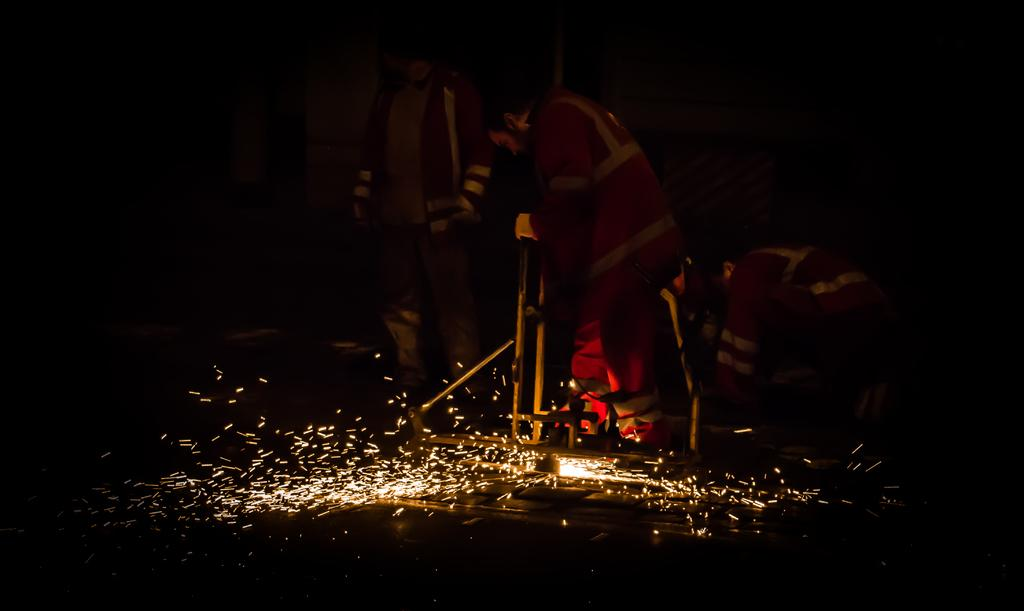What is the main subject of the image? The main subject of the image is a group of people. What are the people wearing in the image? The people are wearing red color jackets. What are the people doing in the image? The people are standing and doing some work. Can you describe any specific detail in the image? There is a spark visible in the image. What type of camp can be seen in the people working in the image? There is no camp present in the image; it features a group of people wearing red color jackets and doing some work. What type of machine is the person using to work with their hands in the image? There is no machine or hand-related work visible in the image; the people are simply standing and doing some work. 